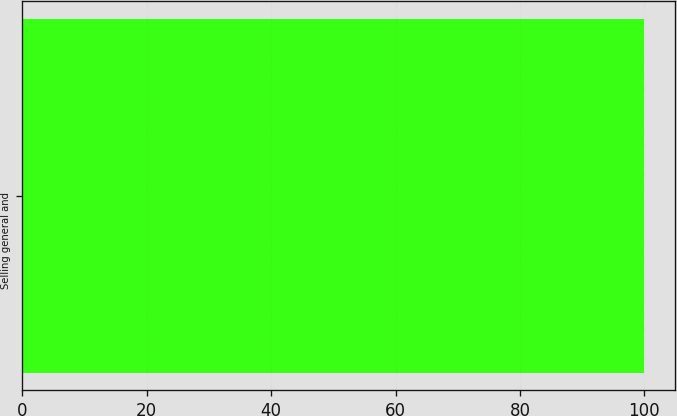Convert chart to OTSL. <chart><loc_0><loc_0><loc_500><loc_500><bar_chart><fcel>Selling general and<nl><fcel>100<nl></chart> 